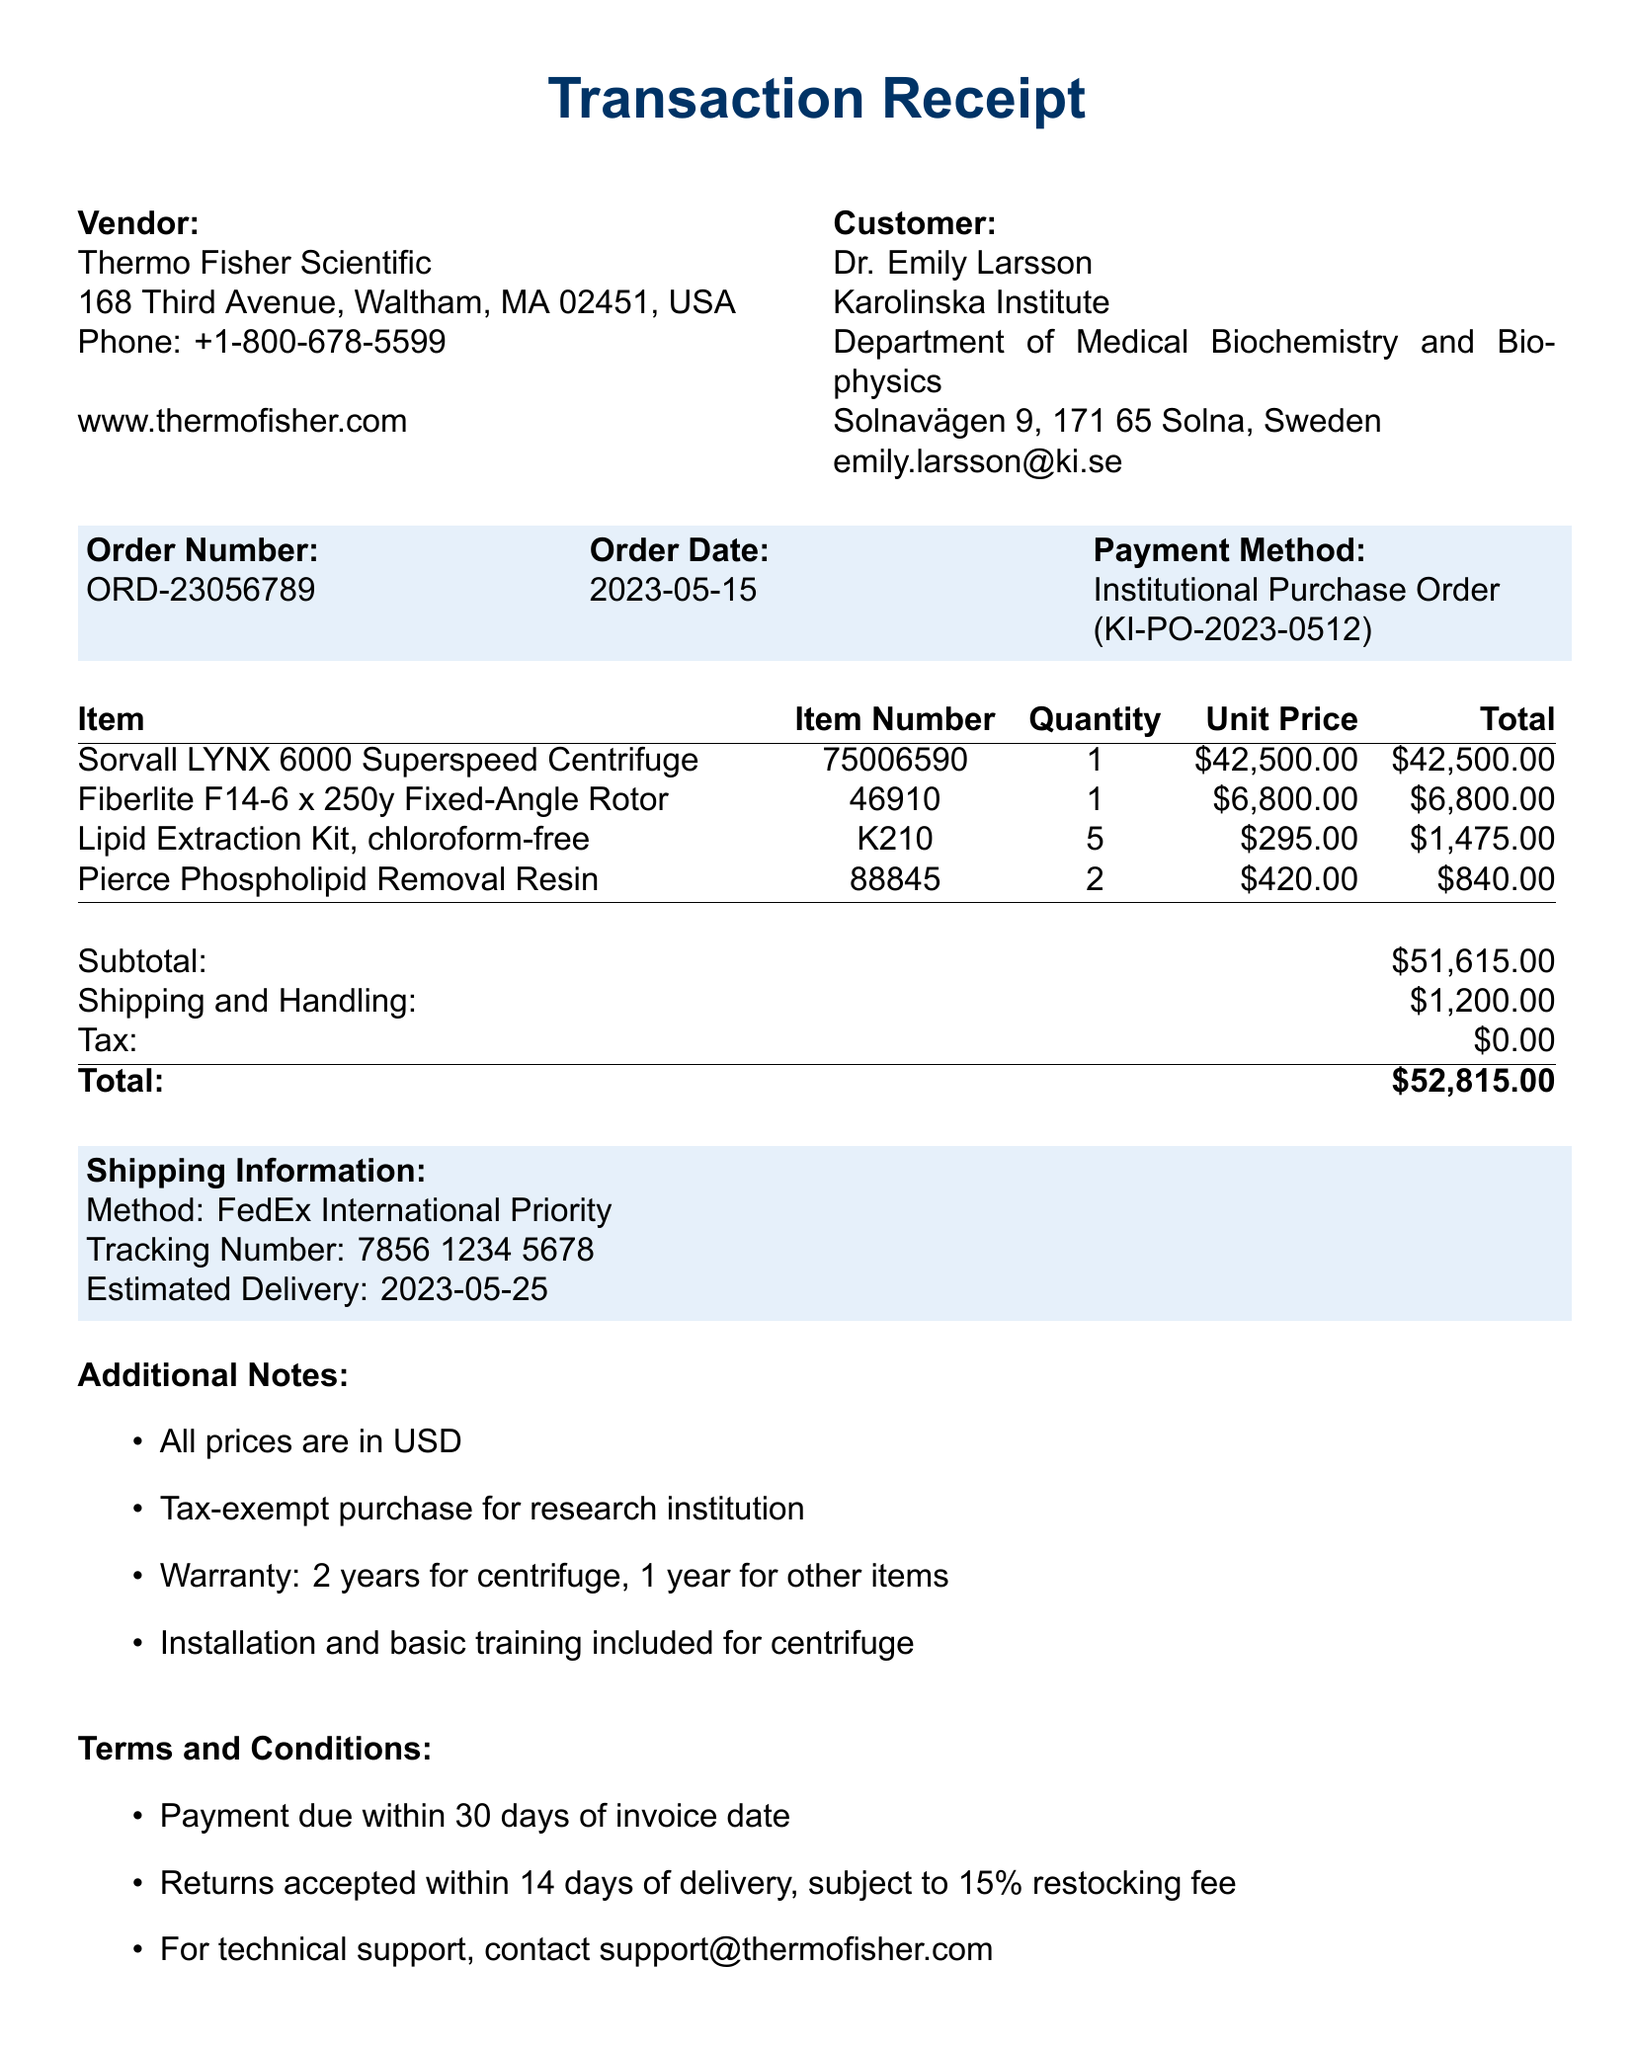What is the vendor name? The vendor name is stated at the top of the document under Vendor information.
Answer: Thermo Fisher Scientific What is the order number? The order number is a specific identifier for the transaction, found in the order details section.
Answer: ORD-23056789 What is the total price of the items? The total price is located in the pricing section, reflecting the overall cost of the transaction.
Answer: $52,815.00 How many Lipid Extraction Kits were purchased? The quantity of Lipid Extraction Kits is specified under item details.
Answer: 5 What is the warranty period for the centrifuge? The warranty period is mentioned in the additional notes section regarding the centrifuge.
Answer: 2 years What payment method was used? The payment method is indicated in the order details section, referencing how the transaction was completed.
Answer: Institutional Purchase Order What is the shipping method? The shipping method is outlined in the shipping information section of the document.
Answer: FedEx International Priority Who should be contacted for technical support? The contact for technical support is provided in the terms and conditions section of the document.
Answer: support@thermofisher.com What is the estimated delivery date? The estimated delivery date can be found in the shipping information section of the document.
Answer: 2023-05-25 